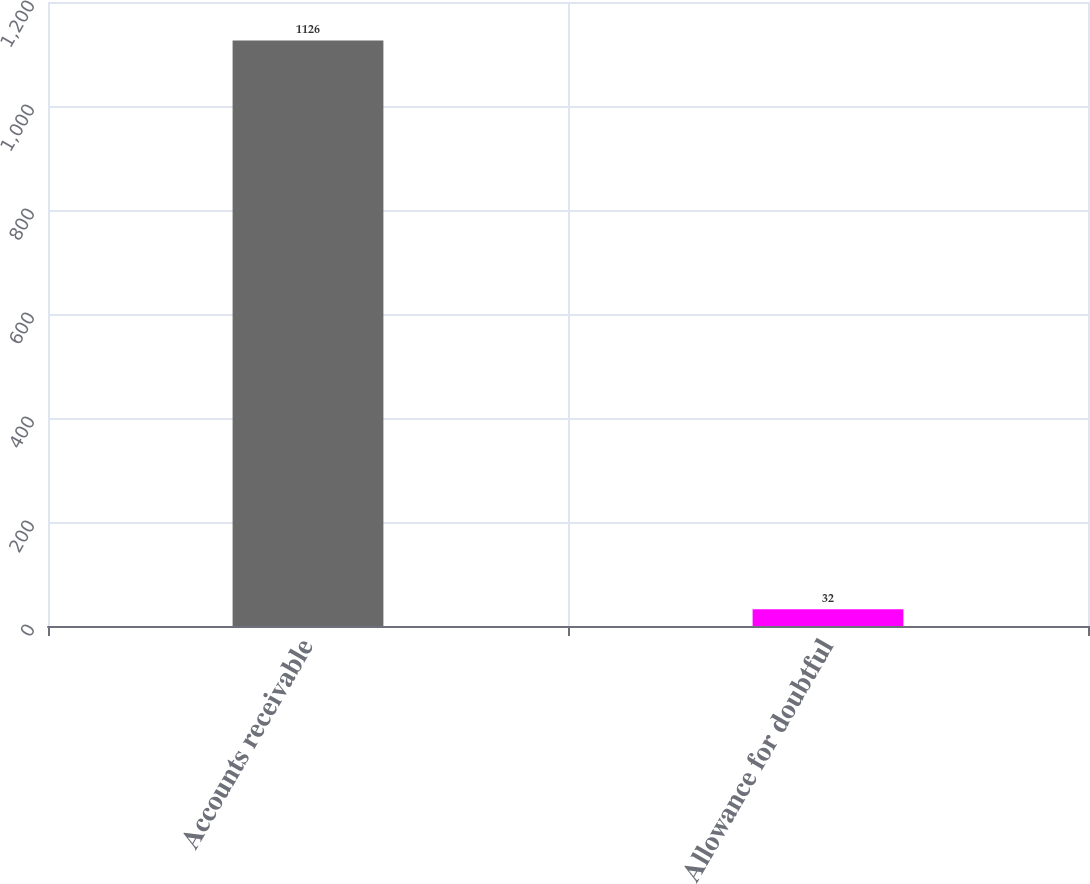Convert chart. <chart><loc_0><loc_0><loc_500><loc_500><bar_chart><fcel>Accounts receivable<fcel>Allowance for doubtful<nl><fcel>1126<fcel>32<nl></chart> 